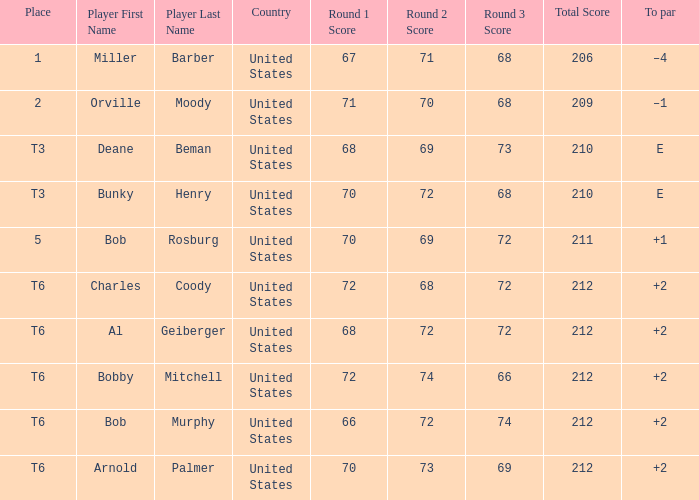What is the place of the 68-69-73=210? T3. 